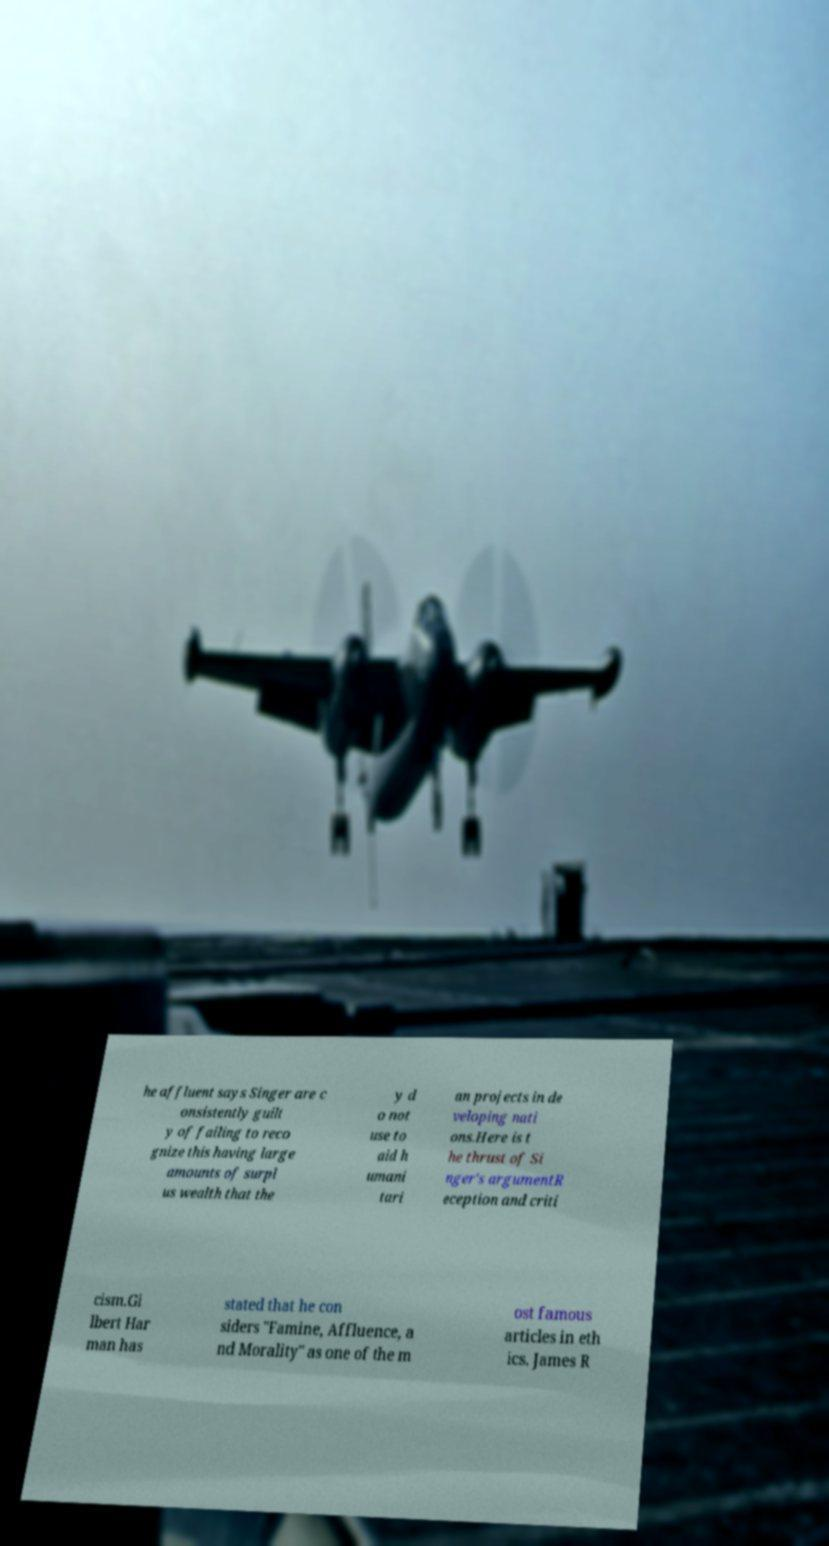Could you extract and type out the text from this image? he affluent says Singer are c onsistently guilt y of failing to reco gnize this having large amounts of surpl us wealth that the y d o not use to aid h umani tari an projects in de veloping nati ons.Here is t he thrust of Si nger's argumentR eception and criti cism.Gi lbert Har man has stated that he con siders "Famine, Affluence, a nd Morality" as one of the m ost famous articles in eth ics. James R 